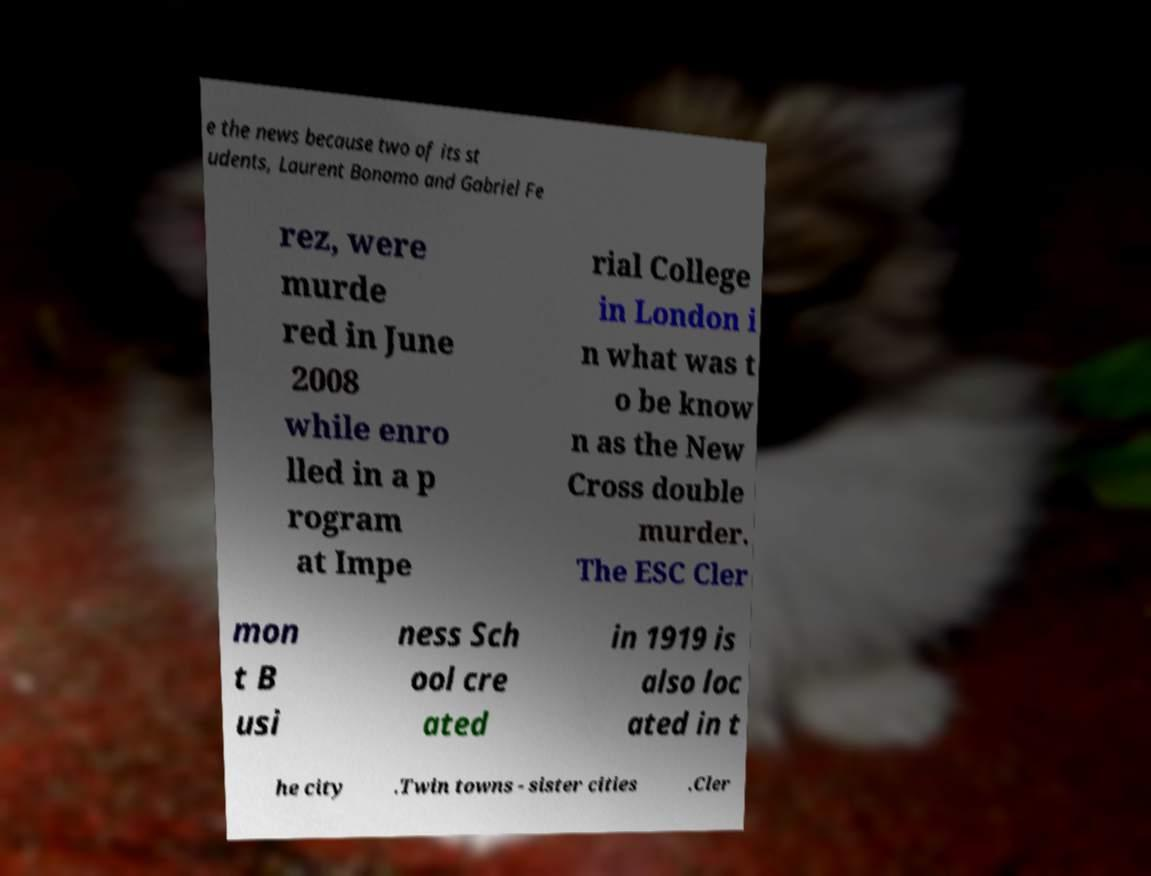Can you accurately transcribe the text from the provided image for me? e the news because two of its st udents, Laurent Bonomo and Gabriel Fe rez, were murde red in June 2008 while enro lled in a p rogram at Impe rial College in London i n what was t o be know n as the New Cross double murder. The ESC Cler mon t B usi ness Sch ool cre ated in 1919 is also loc ated in t he city .Twin towns - sister cities .Cler 